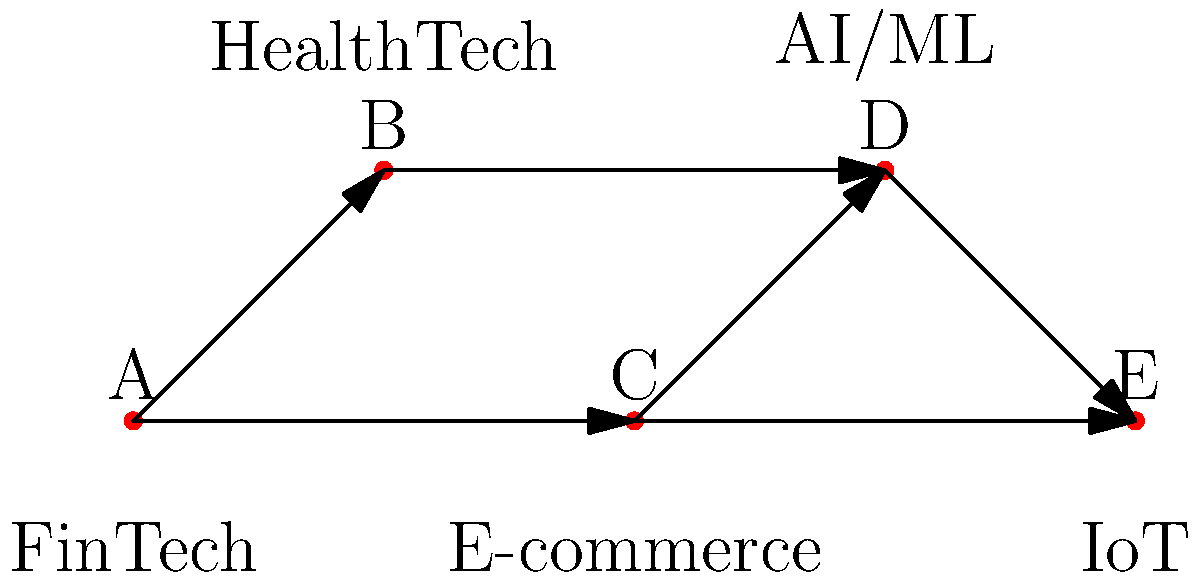In the given graph representing data sharing relationships between startups in different sectors, what is the minimum number of edges that need to be removed to disconnect the FinTech sector (node A) from the IoT sector (node E)? To solve this problem, we need to find the minimum cut between nodes A and E. Let's approach this step-by-step:

1. Identify all possible paths from A to E:
   - Path 1: A -> B -> D -> E
   - Path 2: A -> C -> D -> E
   - Path 3: A -> C -> E

2. Analyze the edges that appear in these paths:
   - Edge A -> B appears in Path 1
   - Edge A -> C appears in Paths 2 and 3
   - Edge B -> D appears in Path 1
   - Edge C -> D appears in Path 2
   - Edge C -> E appears in Path 3
   - Edge D -> E appears in Paths 1 and 2

3. To disconnect A from E, we need to cut all these paths. The minimum number of edges to remove would be:
   - Remove A -> C (cuts Paths 2 and 3)
   - Remove B -> D (cuts Path 1)

4. By removing these two edges, we have effectively disconnected A from E using the minimum number of edge removals.

Therefore, the minimum number of edges that need to be removed to disconnect the FinTech sector (A) from the IoT sector (E) is 2.
Answer: 2 edges 